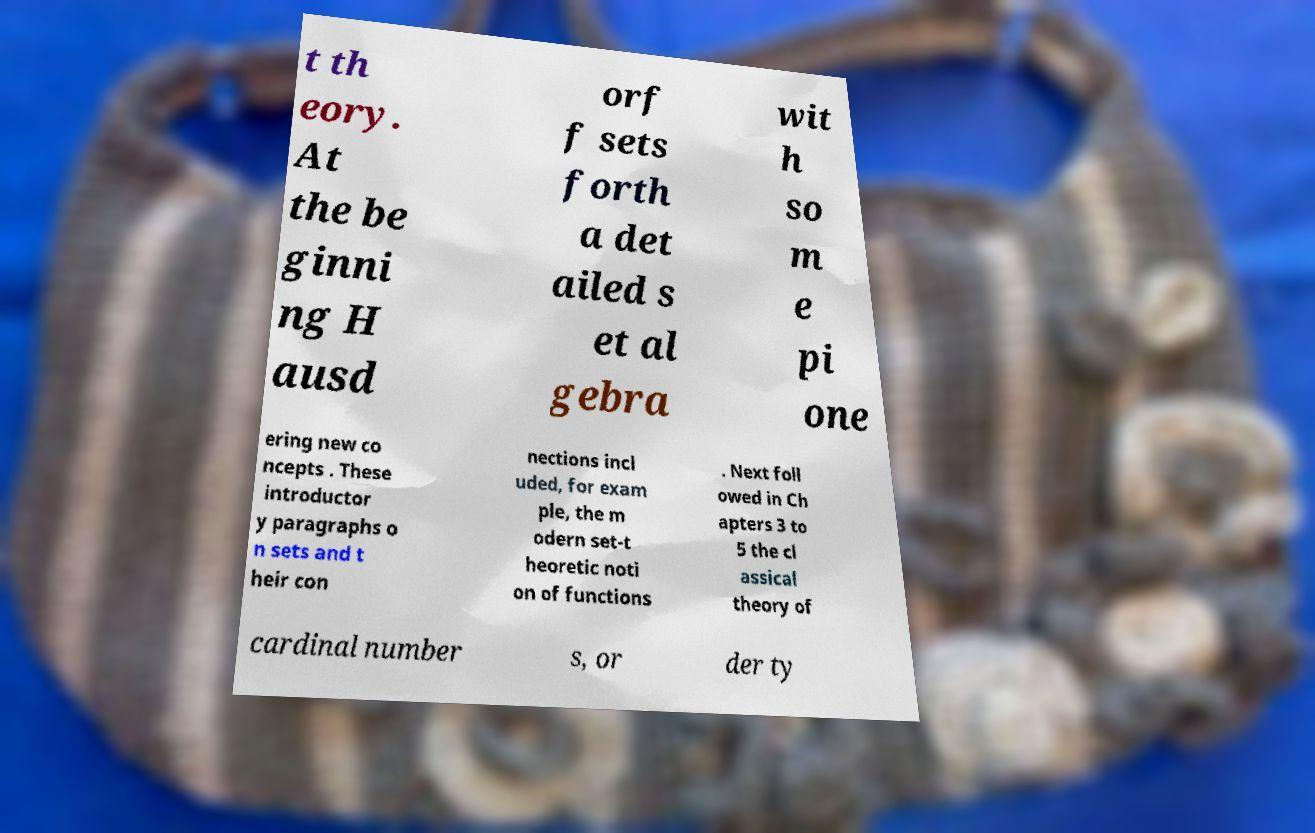Please read and relay the text visible in this image. What does it say? t th eory. At the be ginni ng H ausd orf f sets forth a det ailed s et al gebra wit h so m e pi one ering new co ncepts . These introductor y paragraphs o n sets and t heir con nections incl uded, for exam ple, the m odern set-t heoretic noti on of functions . Next foll owed in Ch apters 3 to 5 the cl assical theory of cardinal number s, or der ty 